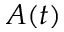<formula> <loc_0><loc_0><loc_500><loc_500>A ( t )</formula> 